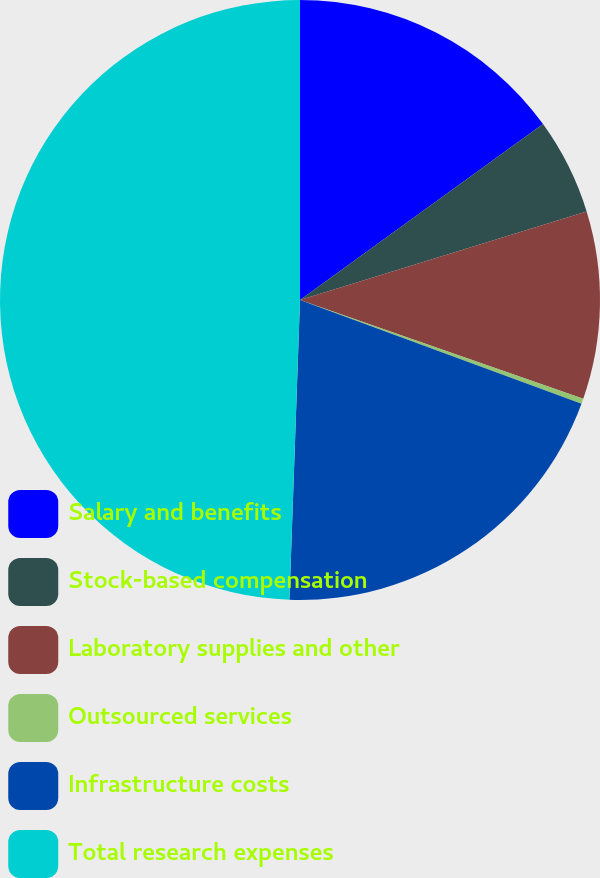Convert chart to OTSL. <chart><loc_0><loc_0><loc_500><loc_500><pie_chart><fcel>Salary and benefits<fcel>Stock-based compensation<fcel>Laboratory supplies and other<fcel>Outsourced services<fcel>Infrastructure costs<fcel>Total research expenses<nl><fcel>15.03%<fcel>5.2%<fcel>10.11%<fcel>0.28%<fcel>19.94%<fcel>49.44%<nl></chart> 